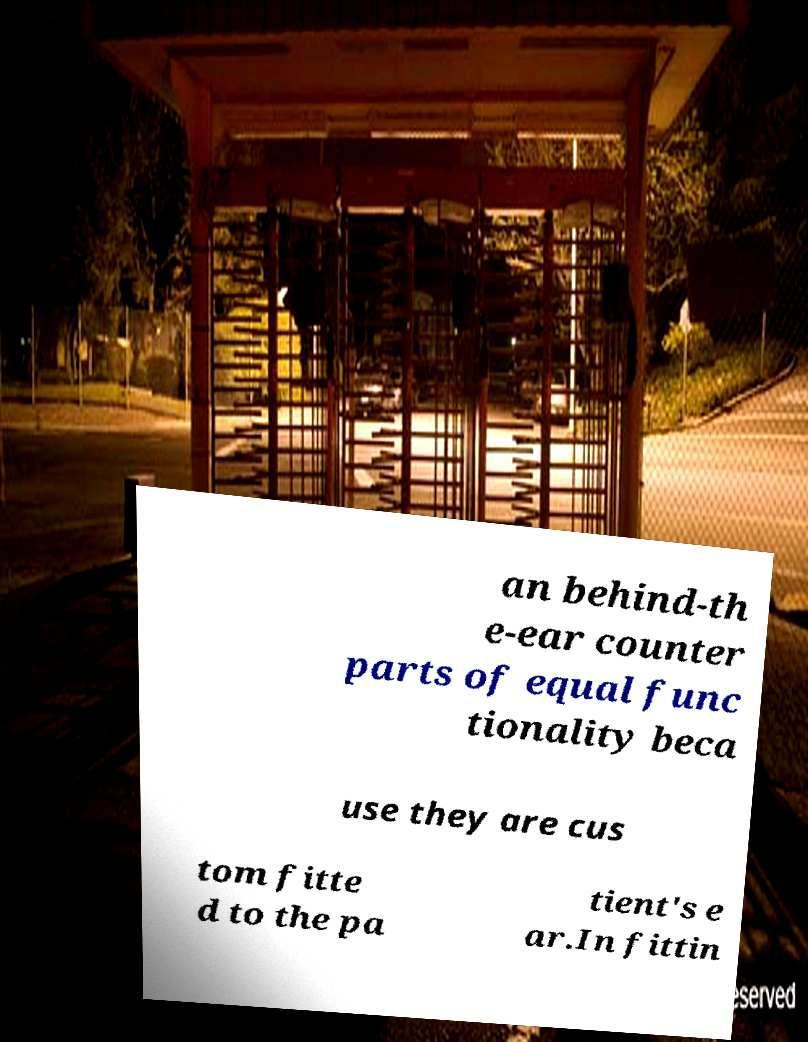Can you accurately transcribe the text from the provided image for me? an behind-th e-ear counter parts of equal func tionality beca use they are cus tom fitte d to the pa tient's e ar.In fittin 